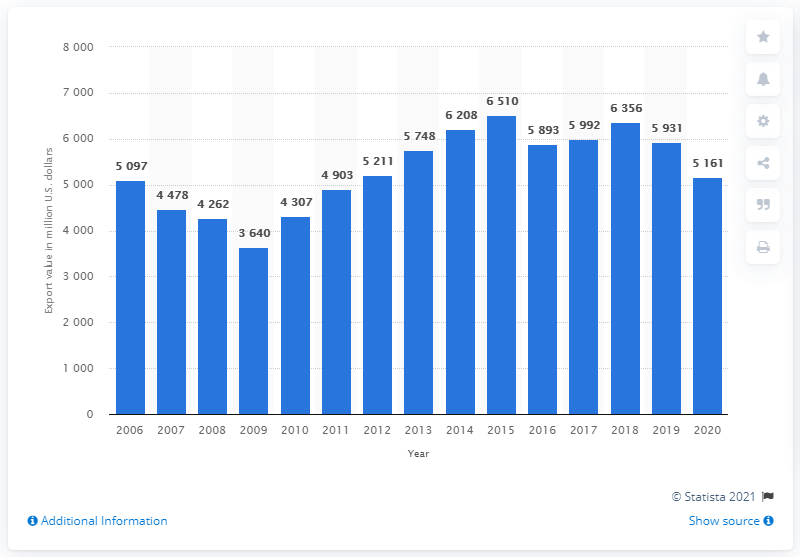Specify some key components in this picture. In 2020, the value of US textile and apparel exports to Mexico was $5,161 million. 